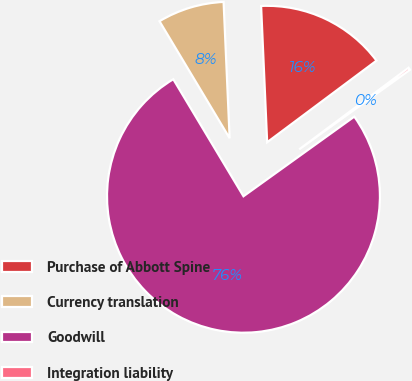Convert chart to OTSL. <chart><loc_0><loc_0><loc_500><loc_500><pie_chart><fcel>Purchase of Abbott Spine<fcel>Currency translation<fcel>Goodwill<fcel>Integration liability<nl><fcel>15.5%<fcel>7.89%<fcel>76.32%<fcel>0.29%<nl></chart> 